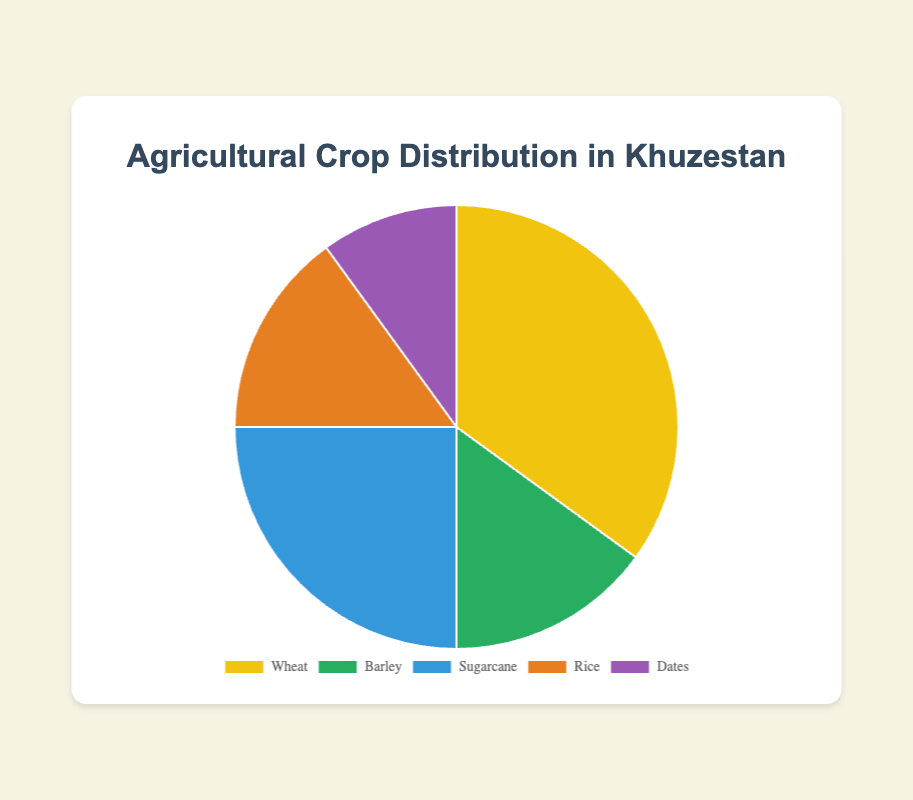What's the most cultivated crop in Khuzestan? The pie chart shows five different crops. Among them, Wheat has the highest percentage at 35%.
Answer: Wheat Which two crops have the same distribution percentage? Referring to the pie chart, Barley and Rice both have a percentage of 15%.
Answer: Barley and Rice What is the percentage difference between Sugarcane and Dates? The percentage for Sugarcane is 25% and for Dates, it is 10%. Subtracting these gives 25% - 10% = 15%.
Answer: 15% What is the total percentage of Barley and Dates combined? Barley is 15% and Dates is 10%. Their combined percentage is 15% + 10% = 25%.
Answer: 25% Which crop occupies a quarter of the total agricultural distribution in Khuzestan? From the pie chart, Sugarcane has a 25% distribution, which is a quarter of the total 100%.
Answer: Sugarcane If the pie chart was divided into two equal halves, which crops together would form an exact half? Wheat has 35%, Barley 15%, and Rice 15%. Adding Wheat (35%) and Sugarcane (25%), we get 60%, which is more than half. Wheat + Barley + Rice (35% + 15% + 15% = 65%) is also more than half. The exact half cannot be formed by these crops in combination.
Answer: Cannot be exactly formed What is the visual color used to represent Rice in the chart? Rice is represented by an orange color in the pie chart.
Answer: Orange How does the percentage of Wheat compare to the sum of Barley and Rice? Wheat has 35% while the sum of Barley and Rice is 15% + 15% = 30%. Since 35% > 30%, Wheat has a higher percentage than the sum of Barley and Rice.
Answer: Wheat has a higher percentage Which crop is represented by the purple color? In the pie chart, Dates is represented by the purple color.
Answer: Dates What is the combined total percentage of the three least cultivated crops in Khuzestan? The least cultivated crops are Barley (15%), Rice (15%), and Dates (10%). Combining these gives 15% + 15% + 10% = 40%.
Answer: 40% 